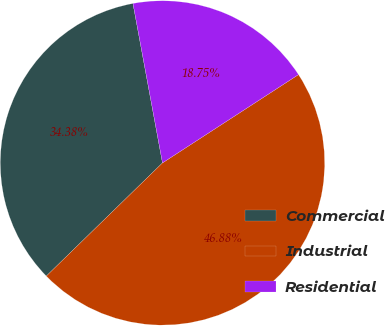Convert chart to OTSL. <chart><loc_0><loc_0><loc_500><loc_500><pie_chart><fcel>Commercial<fcel>Industrial<fcel>Residential<nl><fcel>34.38%<fcel>46.88%<fcel>18.75%<nl></chart> 